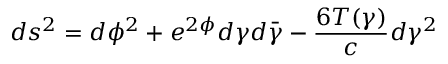<formula> <loc_0><loc_0><loc_500><loc_500>d s ^ { 2 } = d \phi ^ { 2 } + e ^ { 2 \phi } d \gamma d \bar { \gamma } - { \frac { 6 T ( \gamma ) } { c } } d \gamma ^ { 2 }</formula> 